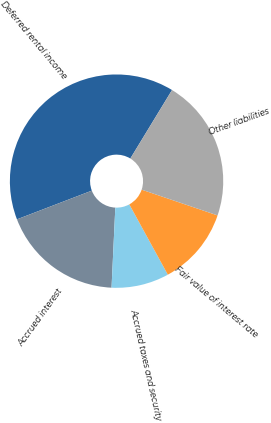Convert chart to OTSL. <chart><loc_0><loc_0><loc_500><loc_500><pie_chart><fcel>Deferred rental income<fcel>Accrued interest<fcel>Accrued taxes and security<fcel>Fair value of interest rate<fcel>Other liabilities<nl><fcel>39.53%<fcel>18.42%<fcel>8.73%<fcel>11.81%<fcel>21.5%<nl></chart> 